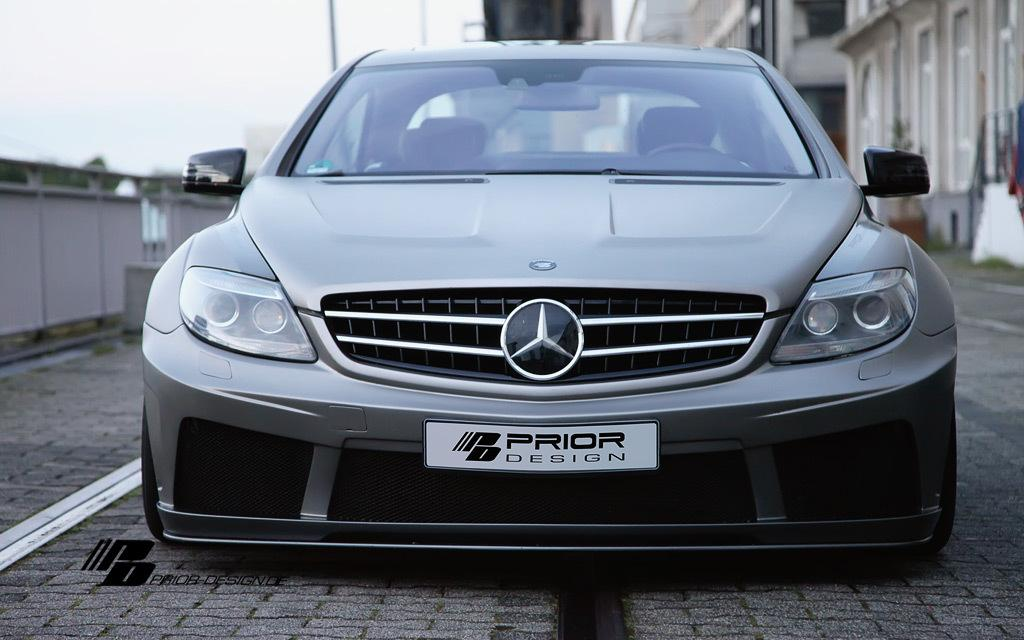What is the main subject of the image? There is a vehicle on the road in the image. What can be seen on the right side of the image? There are buildings on the right side of the image. What is located on the left side of the image? There is a wall on the left side of the image. What type of animal can be seen sitting on the wall in the image? There is no animal present in the image; it only features a vehicle on the road, buildings on the right side, and a wall on the left side. 